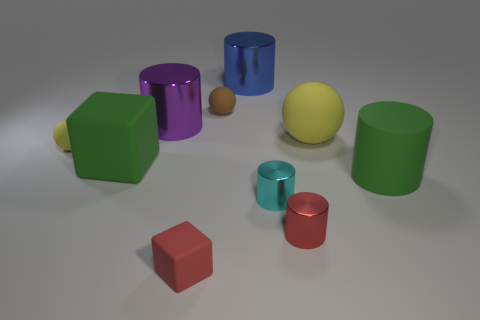Subtract all tiny yellow rubber balls. How many balls are left? 2 Subtract all blue cylinders. How many cylinders are left? 4 Subtract all balls. How many objects are left? 7 Subtract all green cubes. How many yellow balls are left? 2 Subtract 0 gray cubes. How many objects are left? 10 Subtract 3 spheres. How many spheres are left? 0 Subtract all gray blocks. Subtract all blue balls. How many blocks are left? 2 Subtract all small red blocks. Subtract all big yellow things. How many objects are left? 8 Add 5 small brown matte objects. How many small brown matte objects are left? 6 Add 6 large gray spheres. How many large gray spheres exist? 6 